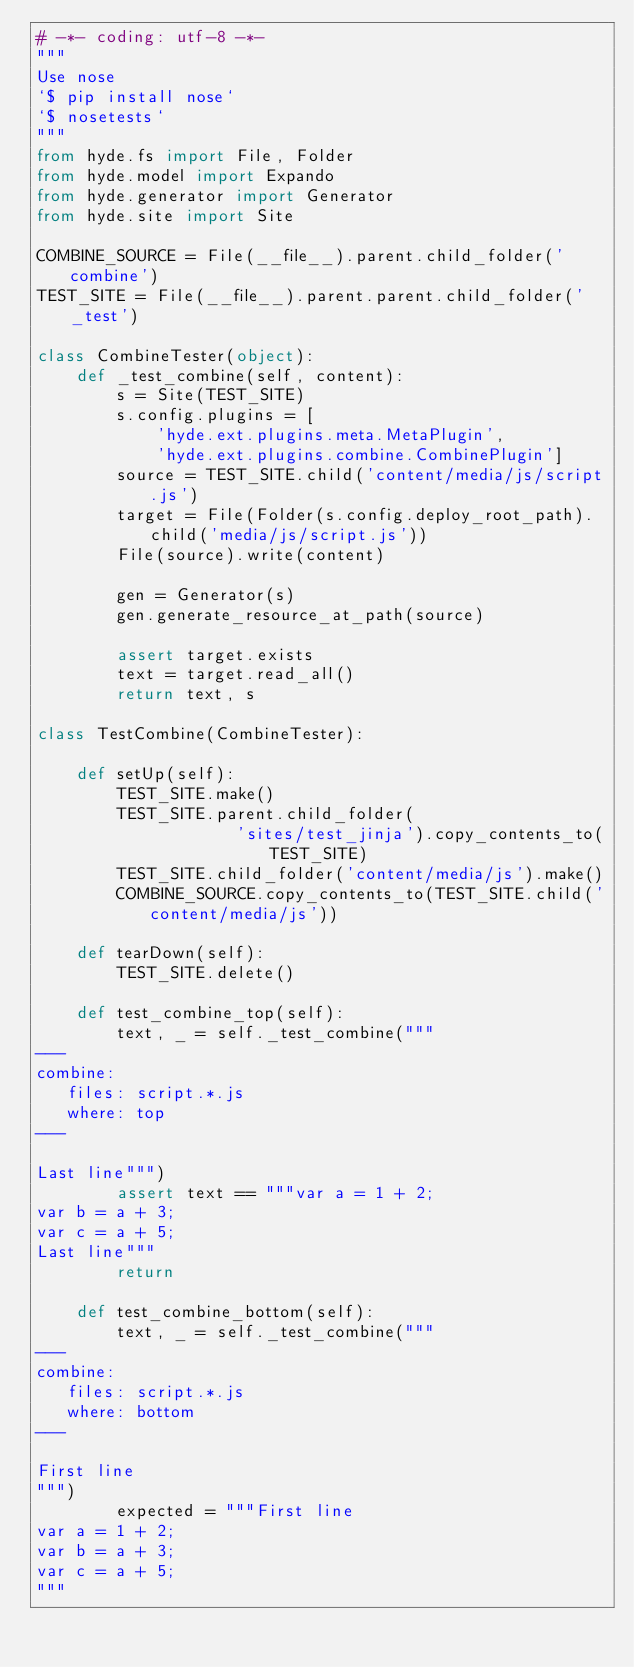<code> <loc_0><loc_0><loc_500><loc_500><_Python_># -*- coding: utf-8 -*-
"""
Use nose
`$ pip install nose`
`$ nosetests`
"""
from hyde.fs import File, Folder
from hyde.model import Expando
from hyde.generator import Generator
from hyde.site import Site

COMBINE_SOURCE = File(__file__).parent.child_folder('combine')
TEST_SITE = File(__file__).parent.parent.child_folder('_test')

class CombineTester(object):
    def _test_combine(self, content):
        s = Site(TEST_SITE)
        s.config.plugins = [
            'hyde.ext.plugins.meta.MetaPlugin',
            'hyde.ext.plugins.combine.CombinePlugin']
        source = TEST_SITE.child('content/media/js/script.js')
        target = File(Folder(s.config.deploy_root_path).child('media/js/script.js'))
        File(source).write(content)

        gen = Generator(s)
        gen.generate_resource_at_path(source)

        assert target.exists
        text = target.read_all()
        return text, s

class TestCombine(CombineTester):

    def setUp(self):
        TEST_SITE.make()
        TEST_SITE.parent.child_folder(
                    'sites/test_jinja').copy_contents_to(TEST_SITE)
        TEST_SITE.child_folder('content/media/js').make()
        COMBINE_SOURCE.copy_contents_to(TEST_SITE.child('content/media/js'))

    def tearDown(self):
        TEST_SITE.delete()

    def test_combine_top(self):
        text, _ = self._test_combine("""
---
combine:
   files: script.*.js
   where: top
---

Last line""")
        assert text == """var a = 1 + 2;
var b = a + 3;
var c = a + 5;
Last line"""
        return

    def test_combine_bottom(self):
        text, _ = self._test_combine("""
---
combine:
   files: script.*.js
   where: bottom
---

First line
""")
        expected = """First line
var a = 1 + 2;
var b = a + 3;
var c = a + 5;
"""
</code> 